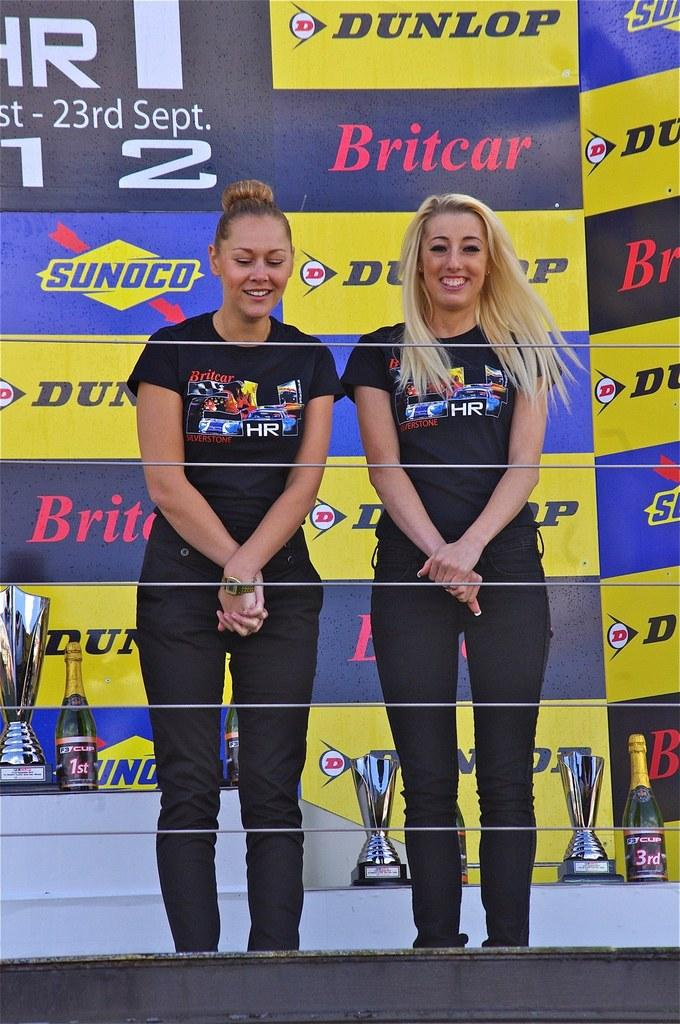<image>
Provide a brief description of the given image. Two females pose in front of a banner representing companies such as Dunlop, Sunoco and Britcar. 